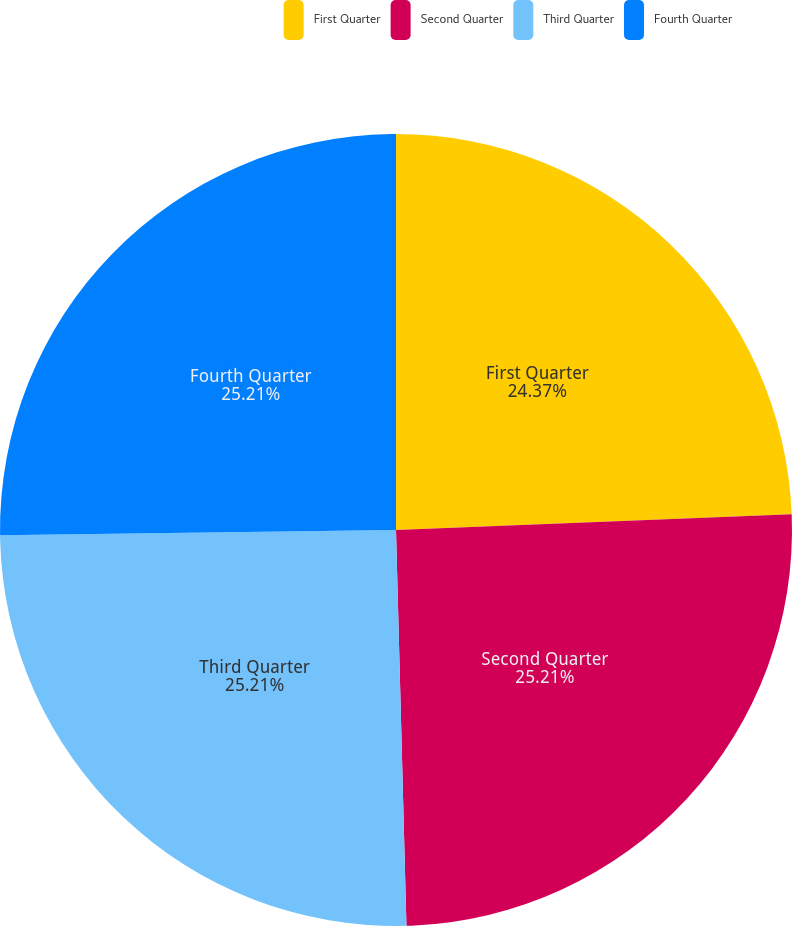Convert chart. <chart><loc_0><loc_0><loc_500><loc_500><pie_chart><fcel>First Quarter<fcel>Second Quarter<fcel>Third Quarter<fcel>Fourth Quarter<nl><fcel>24.37%<fcel>25.21%<fcel>25.21%<fcel>25.21%<nl></chart> 